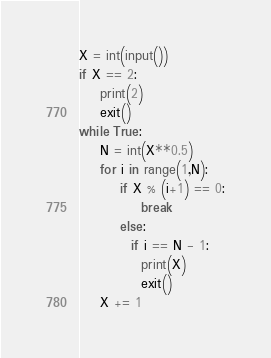<code> <loc_0><loc_0><loc_500><loc_500><_Python_>X = int(input())
if X == 2:
    print(2)
    exit()
while True:
    N = int(X**0.5)
    for i in range(1,N):
        if X % (i+1) == 0:
            break
        else:
          if i == N - 1:
            print(X)
            exit()
    X += 1</code> 